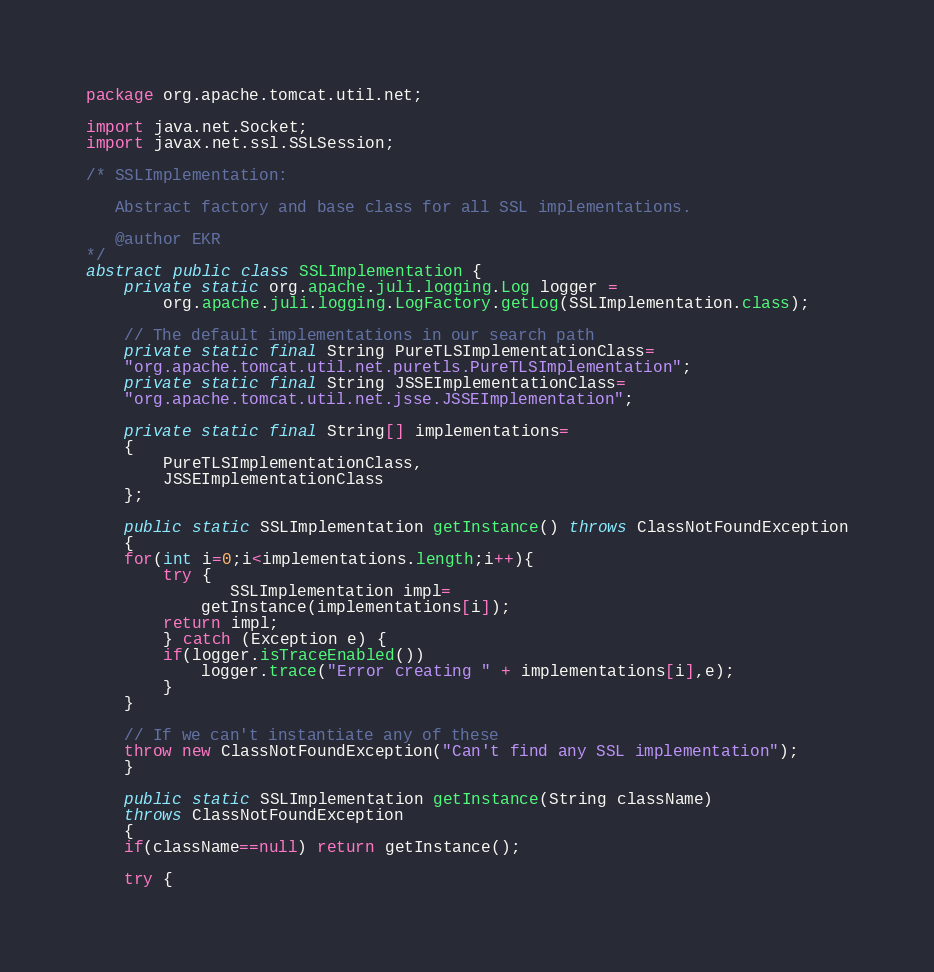<code> <loc_0><loc_0><loc_500><loc_500><_Java_>
package org.apache.tomcat.util.net;

import java.net.Socket;
import javax.net.ssl.SSLSession;

/* SSLImplementation:

   Abstract factory and base class for all SSL implementations.

   @author EKR
*/
abstract public class SSLImplementation {
    private static org.apache.juli.logging.Log logger =
        org.apache.juli.logging.LogFactory.getLog(SSLImplementation.class);

    // The default implementations in our search path
    private static final String PureTLSImplementationClass=
	"org.apache.tomcat.util.net.puretls.PureTLSImplementation";
    private static final String JSSEImplementationClass=
	"org.apache.tomcat.util.net.jsse.JSSEImplementation";
    
    private static final String[] implementations=
    {
        PureTLSImplementationClass,
        JSSEImplementationClass
    };

    public static SSLImplementation getInstance() throws ClassNotFoundException
    {
	for(int i=0;i<implementations.length;i++){
	    try {
               SSLImplementation impl=
		    getInstance(implementations[i]);
		return impl;
	    } catch (Exception e) {
		if(logger.isTraceEnabled()) 
		    logger.trace("Error creating " + implementations[i],e);
	    }
	}

	// If we can't instantiate any of these
	throw new ClassNotFoundException("Can't find any SSL implementation");
    }

    public static SSLImplementation getInstance(String className)
	throws ClassNotFoundException
    {
	if(className==null) return getInstance();

	try {</code> 